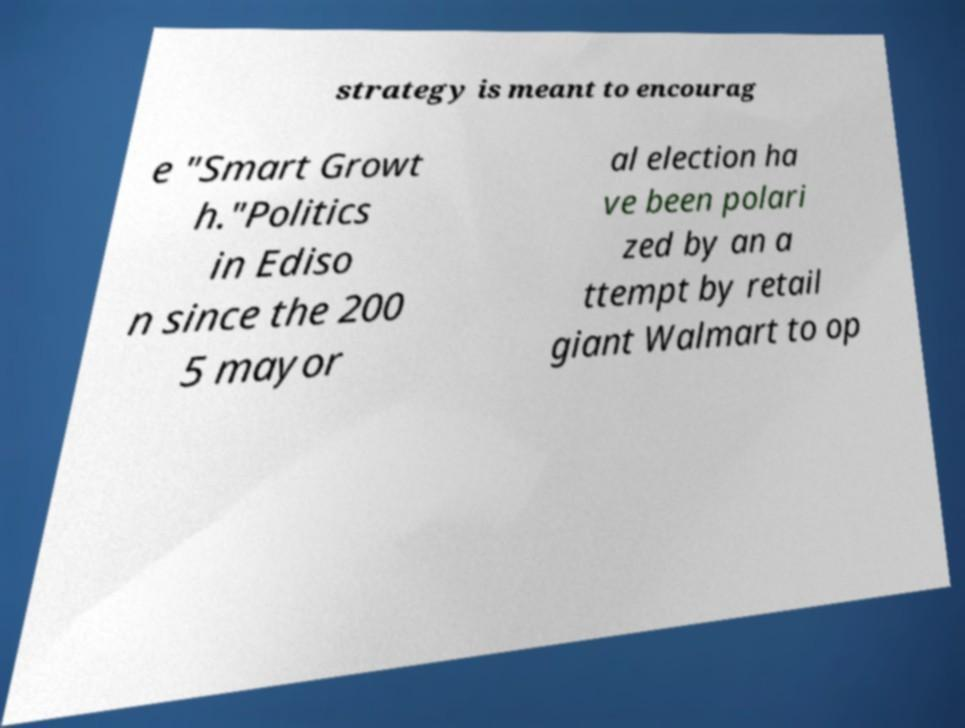Please identify and transcribe the text found in this image. strategy is meant to encourag e "Smart Growt h."Politics in Ediso n since the 200 5 mayor al election ha ve been polari zed by an a ttempt by retail giant Walmart to op 